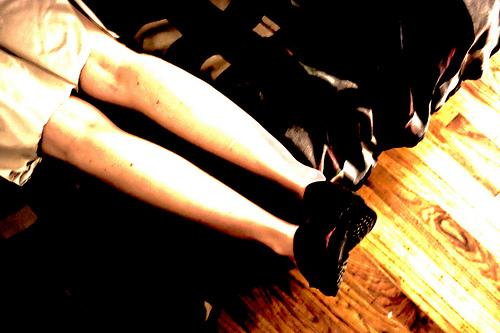What position are the legs in, and what object are they resting upon? The legs are laying down and resting on a bed or a couch. Mention any objects hidden underneath the bed or couch where the person is resting. There are things underneath the bed or couch but their specific details are not clear. Count the number of shoes visible in the image and mention their color. There are two black shoes visible in the image. Describe the appearance of the legs in the image, including any details on the skin and footwear. The legs appear to have shaved pale skin, and the feet are wearing black slippers or shoes. Evaluate and describe the quality of the lighting in the image. The image has a natural sunlight source creating a soft, warm tone with some shadows. Analyze the interaction between the person's legs and the surrounding objects. The legs are resting on the bed or couch with a blanket, and the feet are in contact with the shoes or slippers. What is the color of the shorts worn by the person in the image? The person in the image is wearing white shorts. Identify any visible patterns on the bed's blanket and specify the color. There is a dark plaid pattern with white on the bed's comforter. Explain the appearance of the floor and mention any imperfections. The floor is a light brown wooden floor with natural stains, knots, and varying wood grain patterns. What is the primary focus of the image and where is it placed? The primary focus of the image is a person's legs resting on a bed or couch, placed in the central area. What are some things that might be under the bed? Unknown objects, possibly additional blankets or stored items Write creatively styled caption considering the lowermost portion of the bed. Untold tales hidden beneath the bed's shadows. Notice the big green plant in the corner of the room, beside the wooden floor. Isn't the plant adding a refreshing vibe to the space? Describe the cloth on the bed. There is a black blanket and a brown patch on it. Based on the image, describe the texture of the fabric on the bed. The black blanket on the bed has some noticeable wrinkles. Interpret the shorts string in the photo. The shorts string tie is untied. Can you identify the pink hat on top of the person's head? There is a small pink hat that you may miss if you don't look closely. In the picture, the legs are resting on what? The legs are resting on a bed. Describe the color and length of the shorts on the person in the image. White shorts, above knee length Provide a poetic description of the legs and the wooden floor in the image. Silken legs rest gracefully, where knots and wood entwine, a sunlit dance unfolds. Choose a correct statement for the image: a) The person is wearing white shorts with wrinkles on them, b) The person is wearing red shorts with no wrinkles, c) The person is wearing blue shorts with some wrinkles. a) The person is wearing white shorts with wrinkles on them List different portions of the person's legs in the image. Left leg, right leg, knees Can you find the open book on the coffee table placed near the couch? There's an interesting novel that the person might be reading when they took a break. Observe the colorful painting hanging on the wall above the bed. The painting adds a pleasant touch of creativity to the room. Point out some distinctive features on the wooden floor. Knots, wood grain, sunlight What is the state of the person's skin on their legs in the image? The person's legs have shaved and pale skin. Rate the tone of the image from 1 to 10, where 1 is dull and 10 is vibrant. 6, moderately vibrant Could you point out the adorable puppy lying at the person's feet? There's a cute puppy resting by the black shoes. What kind of flooring is in the image? Light brown wooden floor What type of shoes is the person wearing, and on what surface are they resting? The person is wearing black shoes, and they are resting on a light brown wooden floor. What is the person doing in the image? The person is sitting on a couch with their legs resting on it. Examine the image and comment on the person's shirt. There is no shirt visible in the image. See if you can spot the blue water bottle next to the wooden plank board on the floor. It looks like the person may have been hydrating while resting. Which of the following is an accurate description of the shoes in the image? a) black sneakers, b) brown sandals, c) black slippers c) black slippers 